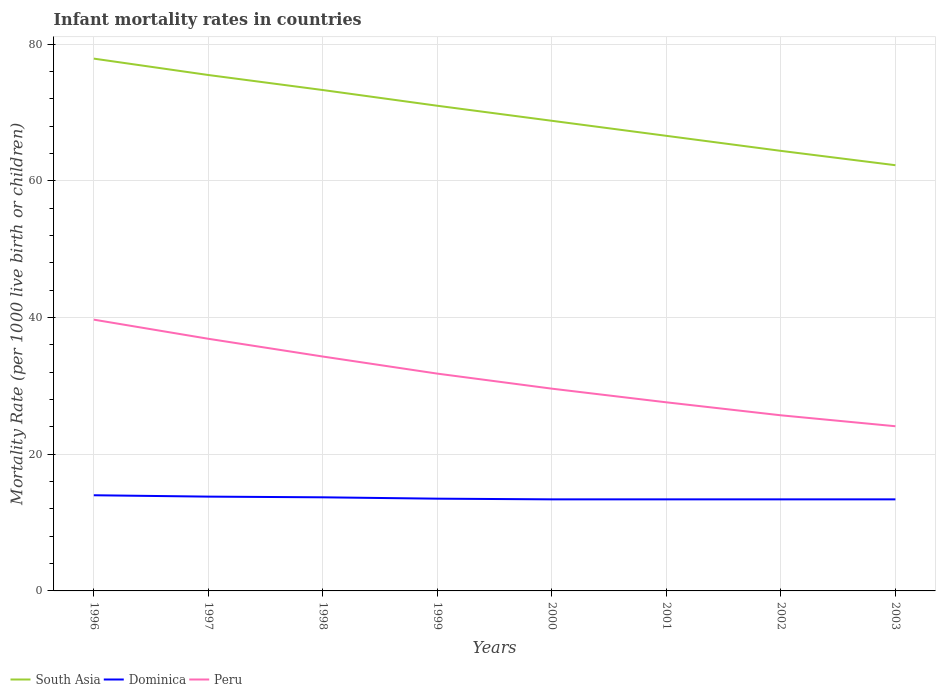Across all years, what is the maximum infant mortality rate in South Asia?
Provide a succinct answer. 62.3. What is the total infant mortality rate in South Asia in the graph?
Offer a terse response. 8.7. What is the difference between the highest and the second highest infant mortality rate in South Asia?
Keep it short and to the point. 15.6. How many lines are there?
Your answer should be very brief. 3. How many years are there in the graph?
Give a very brief answer. 8. What is the difference between two consecutive major ticks on the Y-axis?
Your answer should be compact. 20. Does the graph contain any zero values?
Give a very brief answer. No. Where does the legend appear in the graph?
Provide a succinct answer. Bottom left. What is the title of the graph?
Provide a short and direct response. Infant mortality rates in countries. Does "Channel Islands" appear as one of the legend labels in the graph?
Keep it short and to the point. No. What is the label or title of the X-axis?
Provide a short and direct response. Years. What is the label or title of the Y-axis?
Give a very brief answer. Mortality Rate (per 1000 live birth or children). What is the Mortality Rate (per 1000 live birth or children) of South Asia in 1996?
Keep it short and to the point. 77.9. What is the Mortality Rate (per 1000 live birth or children) in Dominica in 1996?
Give a very brief answer. 14. What is the Mortality Rate (per 1000 live birth or children) in Peru in 1996?
Your response must be concise. 39.7. What is the Mortality Rate (per 1000 live birth or children) in South Asia in 1997?
Offer a terse response. 75.5. What is the Mortality Rate (per 1000 live birth or children) of Peru in 1997?
Ensure brevity in your answer.  36.9. What is the Mortality Rate (per 1000 live birth or children) in South Asia in 1998?
Your response must be concise. 73.3. What is the Mortality Rate (per 1000 live birth or children) in Dominica in 1998?
Ensure brevity in your answer.  13.7. What is the Mortality Rate (per 1000 live birth or children) of Peru in 1998?
Provide a succinct answer. 34.3. What is the Mortality Rate (per 1000 live birth or children) of South Asia in 1999?
Your answer should be very brief. 71. What is the Mortality Rate (per 1000 live birth or children) in Peru in 1999?
Keep it short and to the point. 31.8. What is the Mortality Rate (per 1000 live birth or children) of South Asia in 2000?
Your answer should be compact. 68.8. What is the Mortality Rate (per 1000 live birth or children) in Dominica in 2000?
Provide a short and direct response. 13.4. What is the Mortality Rate (per 1000 live birth or children) of Peru in 2000?
Ensure brevity in your answer.  29.6. What is the Mortality Rate (per 1000 live birth or children) in South Asia in 2001?
Keep it short and to the point. 66.6. What is the Mortality Rate (per 1000 live birth or children) of Dominica in 2001?
Provide a succinct answer. 13.4. What is the Mortality Rate (per 1000 live birth or children) in Peru in 2001?
Make the answer very short. 27.6. What is the Mortality Rate (per 1000 live birth or children) in South Asia in 2002?
Provide a succinct answer. 64.4. What is the Mortality Rate (per 1000 live birth or children) in Peru in 2002?
Offer a terse response. 25.7. What is the Mortality Rate (per 1000 live birth or children) of South Asia in 2003?
Offer a very short reply. 62.3. What is the Mortality Rate (per 1000 live birth or children) in Peru in 2003?
Your answer should be very brief. 24.1. Across all years, what is the maximum Mortality Rate (per 1000 live birth or children) in South Asia?
Your answer should be compact. 77.9. Across all years, what is the maximum Mortality Rate (per 1000 live birth or children) of Dominica?
Your response must be concise. 14. Across all years, what is the maximum Mortality Rate (per 1000 live birth or children) of Peru?
Your answer should be compact. 39.7. Across all years, what is the minimum Mortality Rate (per 1000 live birth or children) in South Asia?
Give a very brief answer. 62.3. Across all years, what is the minimum Mortality Rate (per 1000 live birth or children) of Peru?
Your answer should be compact. 24.1. What is the total Mortality Rate (per 1000 live birth or children) of South Asia in the graph?
Provide a succinct answer. 559.8. What is the total Mortality Rate (per 1000 live birth or children) of Dominica in the graph?
Provide a succinct answer. 108.6. What is the total Mortality Rate (per 1000 live birth or children) in Peru in the graph?
Keep it short and to the point. 249.7. What is the difference between the Mortality Rate (per 1000 live birth or children) of Dominica in 1996 and that in 1997?
Your answer should be compact. 0.2. What is the difference between the Mortality Rate (per 1000 live birth or children) of Dominica in 1996 and that in 1998?
Offer a very short reply. 0.3. What is the difference between the Mortality Rate (per 1000 live birth or children) in Peru in 1996 and that in 1998?
Offer a terse response. 5.4. What is the difference between the Mortality Rate (per 1000 live birth or children) in Peru in 1996 and that in 1999?
Give a very brief answer. 7.9. What is the difference between the Mortality Rate (per 1000 live birth or children) of Dominica in 1996 and that in 2001?
Provide a succinct answer. 0.6. What is the difference between the Mortality Rate (per 1000 live birth or children) in Peru in 1996 and that in 2001?
Keep it short and to the point. 12.1. What is the difference between the Mortality Rate (per 1000 live birth or children) of South Asia in 1996 and that in 2002?
Your answer should be very brief. 13.5. What is the difference between the Mortality Rate (per 1000 live birth or children) in Dominica in 1996 and that in 2002?
Offer a terse response. 0.6. What is the difference between the Mortality Rate (per 1000 live birth or children) of Dominica in 1996 and that in 2003?
Your response must be concise. 0.6. What is the difference between the Mortality Rate (per 1000 live birth or children) in Dominica in 1997 and that in 1998?
Provide a succinct answer. 0.1. What is the difference between the Mortality Rate (per 1000 live birth or children) in Dominica in 1997 and that in 2000?
Offer a terse response. 0.4. What is the difference between the Mortality Rate (per 1000 live birth or children) of Peru in 1997 and that in 2000?
Your answer should be very brief. 7.3. What is the difference between the Mortality Rate (per 1000 live birth or children) of Peru in 1997 and that in 2001?
Ensure brevity in your answer.  9.3. What is the difference between the Mortality Rate (per 1000 live birth or children) of South Asia in 1998 and that in 1999?
Keep it short and to the point. 2.3. What is the difference between the Mortality Rate (per 1000 live birth or children) in Peru in 1998 and that in 1999?
Your response must be concise. 2.5. What is the difference between the Mortality Rate (per 1000 live birth or children) in South Asia in 1998 and that in 2000?
Offer a very short reply. 4.5. What is the difference between the Mortality Rate (per 1000 live birth or children) of Dominica in 1998 and that in 2001?
Provide a succinct answer. 0.3. What is the difference between the Mortality Rate (per 1000 live birth or children) of South Asia in 1998 and that in 2002?
Your response must be concise. 8.9. What is the difference between the Mortality Rate (per 1000 live birth or children) in Dominica in 1998 and that in 2002?
Offer a terse response. 0.3. What is the difference between the Mortality Rate (per 1000 live birth or children) in Peru in 1998 and that in 2002?
Keep it short and to the point. 8.6. What is the difference between the Mortality Rate (per 1000 live birth or children) in Dominica in 1999 and that in 2000?
Provide a succinct answer. 0.1. What is the difference between the Mortality Rate (per 1000 live birth or children) in South Asia in 1999 and that in 2001?
Offer a very short reply. 4.4. What is the difference between the Mortality Rate (per 1000 live birth or children) of Dominica in 1999 and that in 2001?
Keep it short and to the point. 0.1. What is the difference between the Mortality Rate (per 1000 live birth or children) of South Asia in 1999 and that in 2002?
Your answer should be compact. 6.6. What is the difference between the Mortality Rate (per 1000 live birth or children) of Dominica in 1999 and that in 2002?
Your response must be concise. 0.1. What is the difference between the Mortality Rate (per 1000 live birth or children) in Peru in 1999 and that in 2002?
Provide a short and direct response. 6.1. What is the difference between the Mortality Rate (per 1000 live birth or children) of Dominica in 1999 and that in 2003?
Ensure brevity in your answer.  0.1. What is the difference between the Mortality Rate (per 1000 live birth or children) of Peru in 1999 and that in 2003?
Offer a very short reply. 7.7. What is the difference between the Mortality Rate (per 1000 live birth or children) of Dominica in 2000 and that in 2001?
Your answer should be very brief. 0. What is the difference between the Mortality Rate (per 1000 live birth or children) in Peru in 2000 and that in 2001?
Offer a terse response. 2. What is the difference between the Mortality Rate (per 1000 live birth or children) of South Asia in 2000 and that in 2003?
Offer a terse response. 6.5. What is the difference between the Mortality Rate (per 1000 live birth or children) in South Asia in 2001 and that in 2002?
Provide a succinct answer. 2.2. What is the difference between the Mortality Rate (per 1000 live birth or children) in Dominica in 2001 and that in 2002?
Offer a very short reply. 0. What is the difference between the Mortality Rate (per 1000 live birth or children) of South Asia in 2001 and that in 2003?
Your answer should be very brief. 4.3. What is the difference between the Mortality Rate (per 1000 live birth or children) in Dominica in 2001 and that in 2003?
Your answer should be very brief. 0. What is the difference between the Mortality Rate (per 1000 live birth or children) in Dominica in 2002 and that in 2003?
Keep it short and to the point. 0. What is the difference between the Mortality Rate (per 1000 live birth or children) in Peru in 2002 and that in 2003?
Give a very brief answer. 1.6. What is the difference between the Mortality Rate (per 1000 live birth or children) in South Asia in 1996 and the Mortality Rate (per 1000 live birth or children) in Dominica in 1997?
Ensure brevity in your answer.  64.1. What is the difference between the Mortality Rate (per 1000 live birth or children) in Dominica in 1996 and the Mortality Rate (per 1000 live birth or children) in Peru in 1997?
Offer a terse response. -22.9. What is the difference between the Mortality Rate (per 1000 live birth or children) of South Asia in 1996 and the Mortality Rate (per 1000 live birth or children) of Dominica in 1998?
Your answer should be very brief. 64.2. What is the difference between the Mortality Rate (per 1000 live birth or children) of South Asia in 1996 and the Mortality Rate (per 1000 live birth or children) of Peru in 1998?
Give a very brief answer. 43.6. What is the difference between the Mortality Rate (per 1000 live birth or children) in Dominica in 1996 and the Mortality Rate (per 1000 live birth or children) in Peru in 1998?
Make the answer very short. -20.3. What is the difference between the Mortality Rate (per 1000 live birth or children) of South Asia in 1996 and the Mortality Rate (per 1000 live birth or children) of Dominica in 1999?
Offer a very short reply. 64.4. What is the difference between the Mortality Rate (per 1000 live birth or children) in South Asia in 1996 and the Mortality Rate (per 1000 live birth or children) in Peru in 1999?
Your response must be concise. 46.1. What is the difference between the Mortality Rate (per 1000 live birth or children) of Dominica in 1996 and the Mortality Rate (per 1000 live birth or children) of Peru in 1999?
Your response must be concise. -17.8. What is the difference between the Mortality Rate (per 1000 live birth or children) in South Asia in 1996 and the Mortality Rate (per 1000 live birth or children) in Dominica in 2000?
Offer a terse response. 64.5. What is the difference between the Mortality Rate (per 1000 live birth or children) of South Asia in 1996 and the Mortality Rate (per 1000 live birth or children) of Peru in 2000?
Ensure brevity in your answer.  48.3. What is the difference between the Mortality Rate (per 1000 live birth or children) in Dominica in 1996 and the Mortality Rate (per 1000 live birth or children) in Peru in 2000?
Provide a succinct answer. -15.6. What is the difference between the Mortality Rate (per 1000 live birth or children) of South Asia in 1996 and the Mortality Rate (per 1000 live birth or children) of Dominica in 2001?
Offer a terse response. 64.5. What is the difference between the Mortality Rate (per 1000 live birth or children) of South Asia in 1996 and the Mortality Rate (per 1000 live birth or children) of Peru in 2001?
Provide a short and direct response. 50.3. What is the difference between the Mortality Rate (per 1000 live birth or children) in South Asia in 1996 and the Mortality Rate (per 1000 live birth or children) in Dominica in 2002?
Your answer should be very brief. 64.5. What is the difference between the Mortality Rate (per 1000 live birth or children) in South Asia in 1996 and the Mortality Rate (per 1000 live birth or children) in Peru in 2002?
Your answer should be very brief. 52.2. What is the difference between the Mortality Rate (per 1000 live birth or children) of Dominica in 1996 and the Mortality Rate (per 1000 live birth or children) of Peru in 2002?
Provide a succinct answer. -11.7. What is the difference between the Mortality Rate (per 1000 live birth or children) in South Asia in 1996 and the Mortality Rate (per 1000 live birth or children) in Dominica in 2003?
Your answer should be compact. 64.5. What is the difference between the Mortality Rate (per 1000 live birth or children) in South Asia in 1996 and the Mortality Rate (per 1000 live birth or children) in Peru in 2003?
Your response must be concise. 53.8. What is the difference between the Mortality Rate (per 1000 live birth or children) in South Asia in 1997 and the Mortality Rate (per 1000 live birth or children) in Dominica in 1998?
Offer a terse response. 61.8. What is the difference between the Mortality Rate (per 1000 live birth or children) of South Asia in 1997 and the Mortality Rate (per 1000 live birth or children) of Peru in 1998?
Make the answer very short. 41.2. What is the difference between the Mortality Rate (per 1000 live birth or children) of Dominica in 1997 and the Mortality Rate (per 1000 live birth or children) of Peru in 1998?
Your answer should be compact. -20.5. What is the difference between the Mortality Rate (per 1000 live birth or children) in South Asia in 1997 and the Mortality Rate (per 1000 live birth or children) in Peru in 1999?
Offer a terse response. 43.7. What is the difference between the Mortality Rate (per 1000 live birth or children) in Dominica in 1997 and the Mortality Rate (per 1000 live birth or children) in Peru in 1999?
Your response must be concise. -18. What is the difference between the Mortality Rate (per 1000 live birth or children) in South Asia in 1997 and the Mortality Rate (per 1000 live birth or children) in Dominica in 2000?
Your answer should be compact. 62.1. What is the difference between the Mortality Rate (per 1000 live birth or children) of South Asia in 1997 and the Mortality Rate (per 1000 live birth or children) of Peru in 2000?
Provide a short and direct response. 45.9. What is the difference between the Mortality Rate (per 1000 live birth or children) in Dominica in 1997 and the Mortality Rate (per 1000 live birth or children) in Peru in 2000?
Provide a succinct answer. -15.8. What is the difference between the Mortality Rate (per 1000 live birth or children) of South Asia in 1997 and the Mortality Rate (per 1000 live birth or children) of Dominica in 2001?
Your answer should be compact. 62.1. What is the difference between the Mortality Rate (per 1000 live birth or children) in South Asia in 1997 and the Mortality Rate (per 1000 live birth or children) in Peru in 2001?
Your response must be concise. 47.9. What is the difference between the Mortality Rate (per 1000 live birth or children) of South Asia in 1997 and the Mortality Rate (per 1000 live birth or children) of Dominica in 2002?
Your response must be concise. 62.1. What is the difference between the Mortality Rate (per 1000 live birth or children) in South Asia in 1997 and the Mortality Rate (per 1000 live birth or children) in Peru in 2002?
Your response must be concise. 49.8. What is the difference between the Mortality Rate (per 1000 live birth or children) in Dominica in 1997 and the Mortality Rate (per 1000 live birth or children) in Peru in 2002?
Make the answer very short. -11.9. What is the difference between the Mortality Rate (per 1000 live birth or children) of South Asia in 1997 and the Mortality Rate (per 1000 live birth or children) of Dominica in 2003?
Provide a succinct answer. 62.1. What is the difference between the Mortality Rate (per 1000 live birth or children) in South Asia in 1997 and the Mortality Rate (per 1000 live birth or children) in Peru in 2003?
Provide a short and direct response. 51.4. What is the difference between the Mortality Rate (per 1000 live birth or children) in South Asia in 1998 and the Mortality Rate (per 1000 live birth or children) in Dominica in 1999?
Give a very brief answer. 59.8. What is the difference between the Mortality Rate (per 1000 live birth or children) in South Asia in 1998 and the Mortality Rate (per 1000 live birth or children) in Peru in 1999?
Your response must be concise. 41.5. What is the difference between the Mortality Rate (per 1000 live birth or children) in Dominica in 1998 and the Mortality Rate (per 1000 live birth or children) in Peru in 1999?
Keep it short and to the point. -18.1. What is the difference between the Mortality Rate (per 1000 live birth or children) of South Asia in 1998 and the Mortality Rate (per 1000 live birth or children) of Dominica in 2000?
Make the answer very short. 59.9. What is the difference between the Mortality Rate (per 1000 live birth or children) in South Asia in 1998 and the Mortality Rate (per 1000 live birth or children) in Peru in 2000?
Your answer should be very brief. 43.7. What is the difference between the Mortality Rate (per 1000 live birth or children) in Dominica in 1998 and the Mortality Rate (per 1000 live birth or children) in Peru in 2000?
Provide a short and direct response. -15.9. What is the difference between the Mortality Rate (per 1000 live birth or children) in South Asia in 1998 and the Mortality Rate (per 1000 live birth or children) in Dominica in 2001?
Provide a short and direct response. 59.9. What is the difference between the Mortality Rate (per 1000 live birth or children) in South Asia in 1998 and the Mortality Rate (per 1000 live birth or children) in Peru in 2001?
Your response must be concise. 45.7. What is the difference between the Mortality Rate (per 1000 live birth or children) in South Asia in 1998 and the Mortality Rate (per 1000 live birth or children) in Dominica in 2002?
Provide a short and direct response. 59.9. What is the difference between the Mortality Rate (per 1000 live birth or children) of South Asia in 1998 and the Mortality Rate (per 1000 live birth or children) of Peru in 2002?
Make the answer very short. 47.6. What is the difference between the Mortality Rate (per 1000 live birth or children) of South Asia in 1998 and the Mortality Rate (per 1000 live birth or children) of Dominica in 2003?
Keep it short and to the point. 59.9. What is the difference between the Mortality Rate (per 1000 live birth or children) in South Asia in 1998 and the Mortality Rate (per 1000 live birth or children) in Peru in 2003?
Your answer should be compact. 49.2. What is the difference between the Mortality Rate (per 1000 live birth or children) in South Asia in 1999 and the Mortality Rate (per 1000 live birth or children) in Dominica in 2000?
Ensure brevity in your answer.  57.6. What is the difference between the Mortality Rate (per 1000 live birth or children) of South Asia in 1999 and the Mortality Rate (per 1000 live birth or children) of Peru in 2000?
Offer a terse response. 41.4. What is the difference between the Mortality Rate (per 1000 live birth or children) of Dominica in 1999 and the Mortality Rate (per 1000 live birth or children) of Peru in 2000?
Keep it short and to the point. -16.1. What is the difference between the Mortality Rate (per 1000 live birth or children) in South Asia in 1999 and the Mortality Rate (per 1000 live birth or children) in Dominica in 2001?
Offer a very short reply. 57.6. What is the difference between the Mortality Rate (per 1000 live birth or children) of South Asia in 1999 and the Mortality Rate (per 1000 live birth or children) of Peru in 2001?
Keep it short and to the point. 43.4. What is the difference between the Mortality Rate (per 1000 live birth or children) in Dominica in 1999 and the Mortality Rate (per 1000 live birth or children) in Peru in 2001?
Provide a short and direct response. -14.1. What is the difference between the Mortality Rate (per 1000 live birth or children) in South Asia in 1999 and the Mortality Rate (per 1000 live birth or children) in Dominica in 2002?
Your response must be concise. 57.6. What is the difference between the Mortality Rate (per 1000 live birth or children) of South Asia in 1999 and the Mortality Rate (per 1000 live birth or children) of Peru in 2002?
Provide a succinct answer. 45.3. What is the difference between the Mortality Rate (per 1000 live birth or children) in South Asia in 1999 and the Mortality Rate (per 1000 live birth or children) in Dominica in 2003?
Your answer should be very brief. 57.6. What is the difference between the Mortality Rate (per 1000 live birth or children) in South Asia in 1999 and the Mortality Rate (per 1000 live birth or children) in Peru in 2003?
Ensure brevity in your answer.  46.9. What is the difference between the Mortality Rate (per 1000 live birth or children) in Dominica in 1999 and the Mortality Rate (per 1000 live birth or children) in Peru in 2003?
Your response must be concise. -10.6. What is the difference between the Mortality Rate (per 1000 live birth or children) of South Asia in 2000 and the Mortality Rate (per 1000 live birth or children) of Dominica in 2001?
Offer a terse response. 55.4. What is the difference between the Mortality Rate (per 1000 live birth or children) in South Asia in 2000 and the Mortality Rate (per 1000 live birth or children) in Peru in 2001?
Provide a succinct answer. 41.2. What is the difference between the Mortality Rate (per 1000 live birth or children) of South Asia in 2000 and the Mortality Rate (per 1000 live birth or children) of Dominica in 2002?
Offer a terse response. 55.4. What is the difference between the Mortality Rate (per 1000 live birth or children) in South Asia in 2000 and the Mortality Rate (per 1000 live birth or children) in Peru in 2002?
Provide a short and direct response. 43.1. What is the difference between the Mortality Rate (per 1000 live birth or children) of South Asia in 2000 and the Mortality Rate (per 1000 live birth or children) of Dominica in 2003?
Provide a succinct answer. 55.4. What is the difference between the Mortality Rate (per 1000 live birth or children) of South Asia in 2000 and the Mortality Rate (per 1000 live birth or children) of Peru in 2003?
Keep it short and to the point. 44.7. What is the difference between the Mortality Rate (per 1000 live birth or children) in South Asia in 2001 and the Mortality Rate (per 1000 live birth or children) in Dominica in 2002?
Offer a very short reply. 53.2. What is the difference between the Mortality Rate (per 1000 live birth or children) of South Asia in 2001 and the Mortality Rate (per 1000 live birth or children) of Peru in 2002?
Your response must be concise. 40.9. What is the difference between the Mortality Rate (per 1000 live birth or children) in South Asia in 2001 and the Mortality Rate (per 1000 live birth or children) in Dominica in 2003?
Your answer should be very brief. 53.2. What is the difference between the Mortality Rate (per 1000 live birth or children) of South Asia in 2001 and the Mortality Rate (per 1000 live birth or children) of Peru in 2003?
Provide a short and direct response. 42.5. What is the difference between the Mortality Rate (per 1000 live birth or children) of Dominica in 2001 and the Mortality Rate (per 1000 live birth or children) of Peru in 2003?
Keep it short and to the point. -10.7. What is the difference between the Mortality Rate (per 1000 live birth or children) in South Asia in 2002 and the Mortality Rate (per 1000 live birth or children) in Dominica in 2003?
Ensure brevity in your answer.  51. What is the difference between the Mortality Rate (per 1000 live birth or children) in South Asia in 2002 and the Mortality Rate (per 1000 live birth or children) in Peru in 2003?
Offer a very short reply. 40.3. What is the difference between the Mortality Rate (per 1000 live birth or children) of Dominica in 2002 and the Mortality Rate (per 1000 live birth or children) of Peru in 2003?
Offer a terse response. -10.7. What is the average Mortality Rate (per 1000 live birth or children) in South Asia per year?
Offer a very short reply. 69.97. What is the average Mortality Rate (per 1000 live birth or children) in Dominica per year?
Offer a terse response. 13.57. What is the average Mortality Rate (per 1000 live birth or children) in Peru per year?
Offer a terse response. 31.21. In the year 1996, what is the difference between the Mortality Rate (per 1000 live birth or children) of South Asia and Mortality Rate (per 1000 live birth or children) of Dominica?
Your response must be concise. 63.9. In the year 1996, what is the difference between the Mortality Rate (per 1000 live birth or children) of South Asia and Mortality Rate (per 1000 live birth or children) of Peru?
Your answer should be compact. 38.2. In the year 1996, what is the difference between the Mortality Rate (per 1000 live birth or children) in Dominica and Mortality Rate (per 1000 live birth or children) in Peru?
Offer a very short reply. -25.7. In the year 1997, what is the difference between the Mortality Rate (per 1000 live birth or children) in South Asia and Mortality Rate (per 1000 live birth or children) in Dominica?
Offer a very short reply. 61.7. In the year 1997, what is the difference between the Mortality Rate (per 1000 live birth or children) in South Asia and Mortality Rate (per 1000 live birth or children) in Peru?
Provide a succinct answer. 38.6. In the year 1997, what is the difference between the Mortality Rate (per 1000 live birth or children) of Dominica and Mortality Rate (per 1000 live birth or children) of Peru?
Make the answer very short. -23.1. In the year 1998, what is the difference between the Mortality Rate (per 1000 live birth or children) of South Asia and Mortality Rate (per 1000 live birth or children) of Dominica?
Keep it short and to the point. 59.6. In the year 1998, what is the difference between the Mortality Rate (per 1000 live birth or children) of South Asia and Mortality Rate (per 1000 live birth or children) of Peru?
Keep it short and to the point. 39. In the year 1998, what is the difference between the Mortality Rate (per 1000 live birth or children) in Dominica and Mortality Rate (per 1000 live birth or children) in Peru?
Keep it short and to the point. -20.6. In the year 1999, what is the difference between the Mortality Rate (per 1000 live birth or children) of South Asia and Mortality Rate (per 1000 live birth or children) of Dominica?
Your answer should be compact. 57.5. In the year 1999, what is the difference between the Mortality Rate (per 1000 live birth or children) of South Asia and Mortality Rate (per 1000 live birth or children) of Peru?
Make the answer very short. 39.2. In the year 1999, what is the difference between the Mortality Rate (per 1000 live birth or children) of Dominica and Mortality Rate (per 1000 live birth or children) of Peru?
Keep it short and to the point. -18.3. In the year 2000, what is the difference between the Mortality Rate (per 1000 live birth or children) in South Asia and Mortality Rate (per 1000 live birth or children) in Dominica?
Your response must be concise. 55.4. In the year 2000, what is the difference between the Mortality Rate (per 1000 live birth or children) in South Asia and Mortality Rate (per 1000 live birth or children) in Peru?
Your answer should be compact. 39.2. In the year 2000, what is the difference between the Mortality Rate (per 1000 live birth or children) in Dominica and Mortality Rate (per 1000 live birth or children) in Peru?
Make the answer very short. -16.2. In the year 2001, what is the difference between the Mortality Rate (per 1000 live birth or children) of South Asia and Mortality Rate (per 1000 live birth or children) of Dominica?
Give a very brief answer. 53.2. In the year 2001, what is the difference between the Mortality Rate (per 1000 live birth or children) in Dominica and Mortality Rate (per 1000 live birth or children) in Peru?
Make the answer very short. -14.2. In the year 2002, what is the difference between the Mortality Rate (per 1000 live birth or children) of South Asia and Mortality Rate (per 1000 live birth or children) of Peru?
Your response must be concise. 38.7. In the year 2002, what is the difference between the Mortality Rate (per 1000 live birth or children) of Dominica and Mortality Rate (per 1000 live birth or children) of Peru?
Your answer should be very brief. -12.3. In the year 2003, what is the difference between the Mortality Rate (per 1000 live birth or children) in South Asia and Mortality Rate (per 1000 live birth or children) in Dominica?
Give a very brief answer. 48.9. In the year 2003, what is the difference between the Mortality Rate (per 1000 live birth or children) of South Asia and Mortality Rate (per 1000 live birth or children) of Peru?
Make the answer very short. 38.2. What is the ratio of the Mortality Rate (per 1000 live birth or children) in South Asia in 1996 to that in 1997?
Ensure brevity in your answer.  1.03. What is the ratio of the Mortality Rate (per 1000 live birth or children) of Dominica in 1996 to that in 1997?
Keep it short and to the point. 1.01. What is the ratio of the Mortality Rate (per 1000 live birth or children) in Peru in 1996 to that in 1997?
Ensure brevity in your answer.  1.08. What is the ratio of the Mortality Rate (per 1000 live birth or children) of South Asia in 1996 to that in 1998?
Offer a terse response. 1.06. What is the ratio of the Mortality Rate (per 1000 live birth or children) of Dominica in 1996 to that in 1998?
Ensure brevity in your answer.  1.02. What is the ratio of the Mortality Rate (per 1000 live birth or children) of Peru in 1996 to that in 1998?
Offer a terse response. 1.16. What is the ratio of the Mortality Rate (per 1000 live birth or children) of South Asia in 1996 to that in 1999?
Provide a succinct answer. 1.1. What is the ratio of the Mortality Rate (per 1000 live birth or children) in Peru in 1996 to that in 1999?
Give a very brief answer. 1.25. What is the ratio of the Mortality Rate (per 1000 live birth or children) in South Asia in 1996 to that in 2000?
Keep it short and to the point. 1.13. What is the ratio of the Mortality Rate (per 1000 live birth or children) in Dominica in 1996 to that in 2000?
Offer a terse response. 1.04. What is the ratio of the Mortality Rate (per 1000 live birth or children) of Peru in 1996 to that in 2000?
Your answer should be compact. 1.34. What is the ratio of the Mortality Rate (per 1000 live birth or children) in South Asia in 1996 to that in 2001?
Ensure brevity in your answer.  1.17. What is the ratio of the Mortality Rate (per 1000 live birth or children) of Dominica in 1996 to that in 2001?
Your answer should be very brief. 1.04. What is the ratio of the Mortality Rate (per 1000 live birth or children) of Peru in 1996 to that in 2001?
Ensure brevity in your answer.  1.44. What is the ratio of the Mortality Rate (per 1000 live birth or children) in South Asia in 1996 to that in 2002?
Make the answer very short. 1.21. What is the ratio of the Mortality Rate (per 1000 live birth or children) of Dominica in 1996 to that in 2002?
Provide a short and direct response. 1.04. What is the ratio of the Mortality Rate (per 1000 live birth or children) of Peru in 1996 to that in 2002?
Your answer should be compact. 1.54. What is the ratio of the Mortality Rate (per 1000 live birth or children) of South Asia in 1996 to that in 2003?
Your response must be concise. 1.25. What is the ratio of the Mortality Rate (per 1000 live birth or children) in Dominica in 1996 to that in 2003?
Offer a very short reply. 1.04. What is the ratio of the Mortality Rate (per 1000 live birth or children) of Peru in 1996 to that in 2003?
Offer a terse response. 1.65. What is the ratio of the Mortality Rate (per 1000 live birth or children) of Dominica in 1997 to that in 1998?
Give a very brief answer. 1.01. What is the ratio of the Mortality Rate (per 1000 live birth or children) in Peru in 1997 to that in 1998?
Your answer should be very brief. 1.08. What is the ratio of the Mortality Rate (per 1000 live birth or children) of South Asia in 1997 to that in 1999?
Keep it short and to the point. 1.06. What is the ratio of the Mortality Rate (per 1000 live birth or children) in Dominica in 1997 to that in 1999?
Offer a very short reply. 1.02. What is the ratio of the Mortality Rate (per 1000 live birth or children) in Peru in 1997 to that in 1999?
Your answer should be compact. 1.16. What is the ratio of the Mortality Rate (per 1000 live birth or children) of South Asia in 1997 to that in 2000?
Your response must be concise. 1.1. What is the ratio of the Mortality Rate (per 1000 live birth or children) in Dominica in 1997 to that in 2000?
Provide a short and direct response. 1.03. What is the ratio of the Mortality Rate (per 1000 live birth or children) in Peru in 1997 to that in 2000?
Your answer should be very brief. 1.25. What is the ratio of the Mortality Rate (per 1000 live birth or children) in South Asia in 1997 to that in 2001?
Provide a succinct answer. 1.13. What is the ratio of the Mortality Rate (per 1000 live birth or children) of Dominica in 1997 to that in 2001?
Keep it short and to the point. 1.03. What is the ratio of the Mortality Rate (per 1000 live birth or children) in Peru in 1997 to that in 2001?
Your response must be concise. 1.34. What is the ratio of the Mortality Rate (per 1000 live birth or children) of South Asia in 1997 to that in 2002?
Provide a succinct answer. 1.17. What is the ratio of the Mortality Rate (per 1000 live birth or children) in Dominica in 1997 to that in 2002?
Keep it short and to the point. 1.03. What is the ratio of the Mortality Rate (per 1000 live birth or children) in Peru in 1997 to that in 2002?
Ensure brevity in your answer.  1.44. What is the ratio of the Mortality Rate (per 1000 live birth or children) in South Asia in 1997 to that in 2003?
Provide a short and direct response. 1.21. What is the ratio of the Mortality Rate (per 1000 live birth or children) in Dominica in 1997 to that in 2003?
Give a very brief answer. 1.03. What is the ratio of the Mortality Rate (per 1000 live birth or children) of Peru in 1997 to that in 2003?
Give a very brief answer. 1.53. What is the ratio of the Mortality Rate (per 1000 live birth or children) of South Asia in 1998 to that in 1999?
Offer a terse response. 1.03. What is the ratio of the Mortality Rate (per 1000 live birth or children) of Dominica in 1998 to that in 1999?
Your response must be concise. 1.01. What is the ratio of the Mortality Rate (per 1000 live birth or children) of Peru in 1998 to that in 1999?
Offer a very short reply. 1.08. What is the ratio of the Mortality Rate (per 1000 live birth or children) in South Asia in 1998 to that in 2000?
Make the answer very short. 1.07. What is the ratio of the Mortality Rate (per 1000 live birth or children) in Dominica in 1998 to that in 2000?
Your answer should be very brief. 1.02. What is the ratio of the Mortality Rate (per 1000 live birth or children) in Peru in 1998 to that in 2000?
Your response must be concise. 1.16. What is the ratio of the Mortality Rate (per 1000 live birth or children) of South Asia in 1998 to that in 2001?
Give a very brief answer. 1.1. What is the ratio of the Mortality Rate (per 1000 live birth or children) in Dominica in 1998 to that in 2001?
Your response must be concise. 1.02. What is the ratio of the Mortality Rate (per 1000 live birth or children) of Peru in 1998 to that in 2001?
Your answer should be compact. 1.24. What is the ratio of the Mortality Rate (per 1000 live birth or children) in South Asia in 1998 to that in 2002?
Your answer should be compact. 1.14. What is the ratio of the Mortality Rate (per 1000 live birth or children) in Dominica in 1998 to that in 2002?
Your answer should be very brief. 1.02. What is the ratio of the Mortality Rate (per 1000 live birth or children) of Peru in 1998 to that in 2002?
Your answer should be very brief. 1.33. What is the ratio of the Mortality Rate (per 1000 live birth or children) of South Asia in 1998 to that in 2003?
Ensure brevity in your answer.  1.18. What is the ratio of the Mortality Rate (per 1000 live birth or children) of Dominica in 1998 to that in 2003?
Ensure brevity in your answer.  1.02. What is the ratio of the Mortality Rate (per 1000 live birth or children) in Peru in 1998 to that in 2003?
Offer a terse response. 1.42. What is the ratio of the Mortality Rate (per 1000 live birth or children) in South Asia in 1999 to that in 2000?
Offer a terse response. 1.03. What is the ratio of the Mortality Rate (per 1000 live birth or children) of Dominica in 1999 to that in 2000?
Your answer should be very brief. 1.01. What is the ratio of the Mortality Rate (per 1000 live birth or children) in Peru in 1999 to that in 2000?
Keep it short and to the point. 1.07. What is the ratio of the Mortality Rate (per 1000 live birth or children) of South Asia in 1999 to that in 2001?
Your answer should be very brief. 1.07. What is the ratio of the Mortality Rate (per 1000 live birth or children) in Dominica in 1999 to that in 2001?
Your answer should be very brief. 1.01. What is the ratio of the Mortality Rate (per 1000 live birth or children) in Peru in 1999 to that in 2001?
Offer a terse response. 1.15. What is the ratio of the Mortality Rate (per 1000 live birth or children) of South Asia in 1999 to that in 2002?
Provide a succinct answer. 1.1. What is the ratio of the Mortality Rate (per 1000 live birth or children) in Dominica in 1999 to that in 2002?
Provide a succinct answer. 1.01. What is the ratio of the Mortality Rate (per 1000 live birth or children) in Peru in 1999 to that in 2002?
Ensure brevity in your answer.  1.24. What is the ratio of the Mortality Rate (per 1000 live birth or children) in South Asia in 1999 to that in 2003?
Ensure brevity in your answer.  1.14. What is the ratio of the Mortality Rate (per 1000 live birth or children) in Dominica in 1999 to that in 2003?
Provide a succinct answer. 1.01. What is the ratio of the Mortality Rate (per 1000 live birth or children) in Peru in 1999 to that in 2003?
Your response must be concise. 1.32. What is the ratio of the Mortality Rate (per 1000 live birth or children) in South Asia in 2000 to that in 2001?
Provide a succinct answer. 1.03. What is the ratio of the Mortality Rate (per 1000 live birth or children) of Dominica in 2000 to that in 2001?
Keep it short and to the point. 1. What is the ratio of the Mortality Rate (per 1000 live birth or children) in Peru in 2000 to that in 2001?
Provide a short and direct response. 1.07. What is the ratio of the Mortality Rate (per 1000 live birth or children) in South Asia in 2000 to that in 2002?
Give a very brief answer. 1.07. What is the ratio of the Mortality Rate (per 1000 live birth or children) in Peru in 2000 to that in 2002?
Ensure brevity in your answer.  1.15. What is the ratio of the Mortality Rate (per 1000 live birth or children) in South Asia in 2000 to that in 2003?
Provide a succinct answer. 1.1. What is the ratio of the Mortality Rate (per 1000 live birth or children) in Peru in 2000 to that in 2003?
Give a very brief answer. 1.23. What is the ratio of the Mortality Rate (per 1000 live birth or children) of South Asia in 2001 to that in 2002?
Offer a terse response. 1.03. What is the ratio of the Mortality Rate (per 1000 live birth or children) in Dominica in 2001 to that in 2002?
Provide a short and direct response. 1. What is the ratio of the Mortality Rate (per 1000 live birth or children) of Peru in 2001 to that in 2002?
Offer a very short reply. 1.07. What is the ratio of the Mortality Rate (per 1000 live birth or children) of South Asia in 2001 to that in 2003?
Your response must be concise. 1.07. What is the ratio of the Mortality Rate (per 1000 live birth or children) in Peru in 2001 to that in 2003?
Ensure brevity in your answer.  1.15. What is the ratio of the Mortality Rate (per 1000 live birth or children) in South Asia in 2002 to that in 2003?
Keep it short and to the point. 1.03. What is the ratio of the Mortality Rate (per 1000 live birth or children) of Peru in 2002 to that in 2003?
Give a very brief answer. 1.07. What is the difference between the highest and the second highest Mortality Rate (per 1000 live birth or children) in Peru?
Your response must be concise. 2.8. What is the difference between the highest and the lowest Mortality Rate (per 1000 live birth or children) of Peru?
Give a very brief answer. 15.6. 